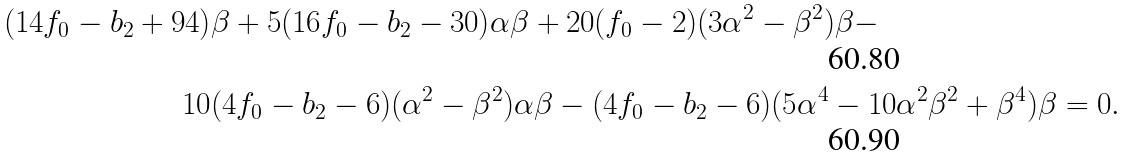Convert formula to latex. <formula><loc_0><loc_0><loc_500><loc_500>( 1 4 f _ { 0 } - b _ { 2 } + 9 4 ) & \beta + 5 ( 1 6 f _ { 0 } - b _ { 2 } - 3 0 ) \alpha \beta + 2 0 ( f _ { 0 } - 2 ) ( 3 \alpha ^ { 2 } - \beta ^ { 2 } ) \beta - \\ 1 0 & ( 4 f _ { 0 } - b _ { 2 } - 6 ) ( \alpha ^ { 2 } - \beta ^ { 2 } ) \alpha \beta - ( 4 f _ { 0 } - b _ { 2 } - 6 ) ( 5 \alpha ^ { 4 } - 1 0 \alpha ^ { 2 } \beta ^ { 2 } + \beta ^ { 4 } ) \beta = 0 .</formula> 